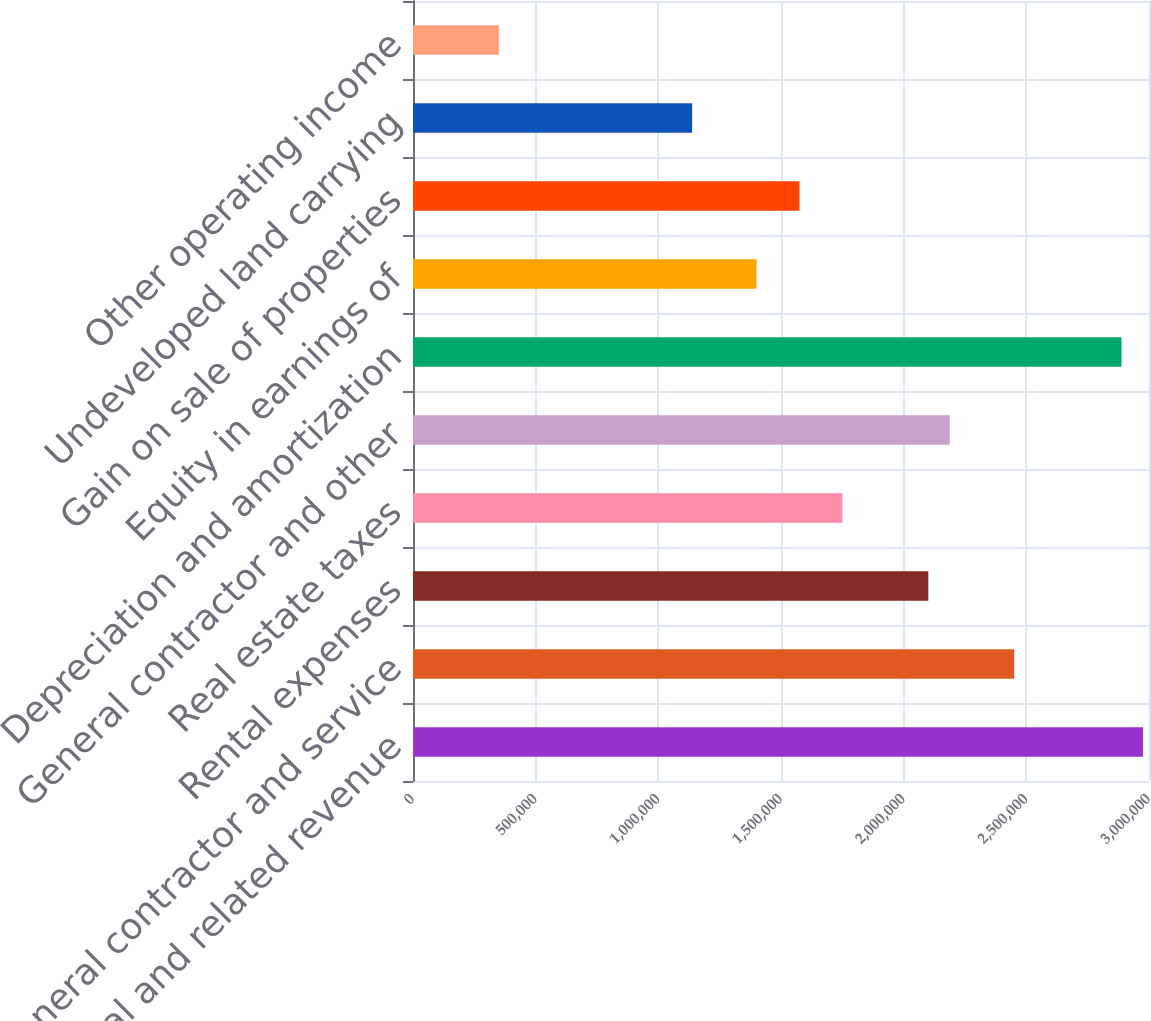<chart> <loc_0><loc_0><loc_500><loc_500><bar_chart><fcel>Rental and related revenue<fcel>General contractor and service<fcel>Rental expenses<fcel>Real estate taxes<fcel>General contractor and other<fcel>Depreciation and amortization<fcel>Equity in earnings of<fcel>Gain on sale of properties<fcel>Undeveloped land carrying<fcel>Other operating income<nl><fcel>2.97566e+06<fcel>2.45054e+06<fcel>2.10047e+06<fcel>1.75039e+06<fcel>2.18798e+06<fcel>2.88814e+06<fcel>1.40031e+06<fcel>1.57535e+06<fcel>1.13775e+06<fcel>350078<nl></chart> 